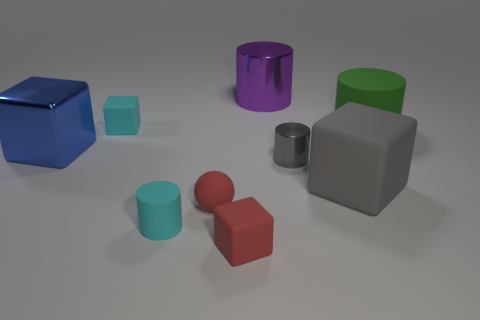Subtract all cyan cylinders. How many cylinders are left? 3 Subtract all red cylinders. Subtract all blue blocks. How many cylinders are left? 4 Add 1 large yellow matte balls. How many objects exist? 10 Subtract all balls. How many objects are left? 8 Add 5 purple shiny things. How many purple shiny things exist? 6 Subtract 0 brown cylinders. How many objects are left? 9 Subtract all cyan objects. Subtract all big matte blocks. How many objects are left? 6 Add 1 red objects. How many red objects are left? 3 